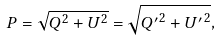<formula> <loc_0><loc_0><loc_500><loc_500>P = \sqrt { Q ^ { 2 } + U ^ { 2 } } = \sqrt { { Q ^ { \prime } } ^ { 2 } + { U ^ { \prime } } ^ { 2 } } ,</formula> 